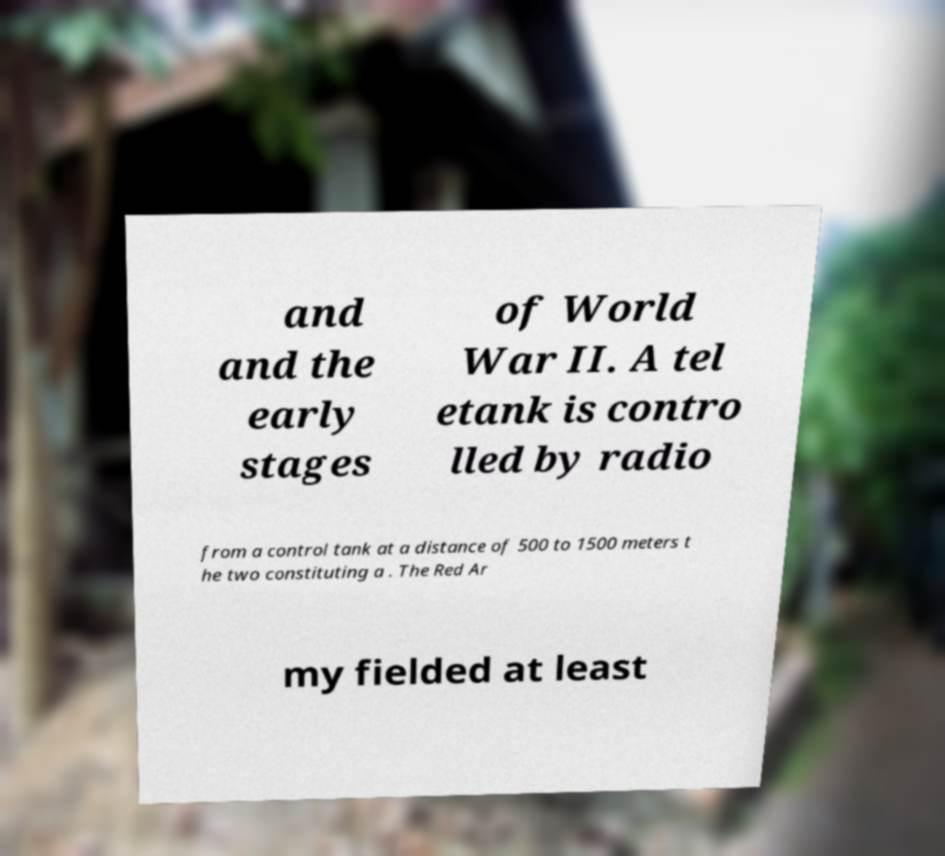I need the written content from this picture converted into text. Can you do that? and and the early stages of World War II. A tel etank is contro lled by radio from a control tank at a distance of 500 to 1500 meters t he two constituting a . The Red Ar my fielded at least 